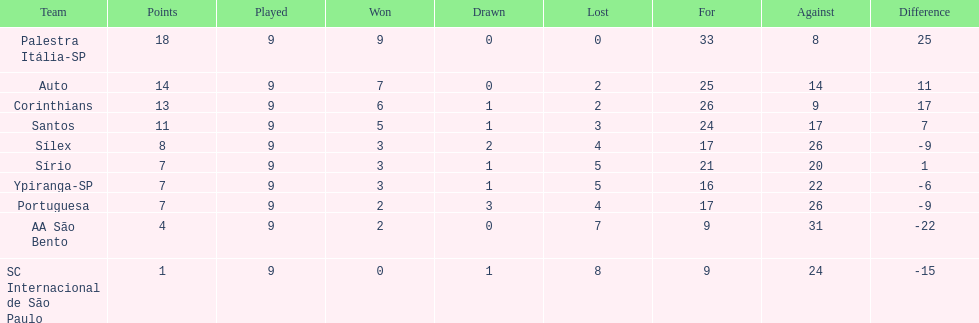Could you parse the entire table as a dict? {'header': ['Team', 'Points', 'Played', 'Won', 'Drawn', 'Lost', 'For', 'Against', 'Difference'], 'rows': [['Palestra Itália-SP', '18', '9', '9', '0', '0', '33', '8', '25'], ['Auto', '14', '9', '7', '0', '2', '25', '14', '11'], ['Corinthians', '13', '9', '6', '1', '2', '26', '9', '17'], ['Santos', '11', '9', '5', '1', '3', '24', '17', '7'], ['Sílex', '8', '9', '3', '2', '4', '17', '26', '-9'], ['Sírio', '7', '9', '3', '1', '5', '21', '20', '1'], ['Ypiranga-SP', '7', '9', '3', '1', '5', '16', '22', '-6'], ['Portuguesa', '7', '9', '2', '3', '4', '17', '26', '-9'], ['AA São Bento', '4', '9', '2', '0', '7', '9', '31', '-22'], ['SC Internacional de São Paulo', '1', '9', '0', '1', '8', '9', '24', '-15']]} In 1926 brazilian football,what was the total number of points scored? 90. 